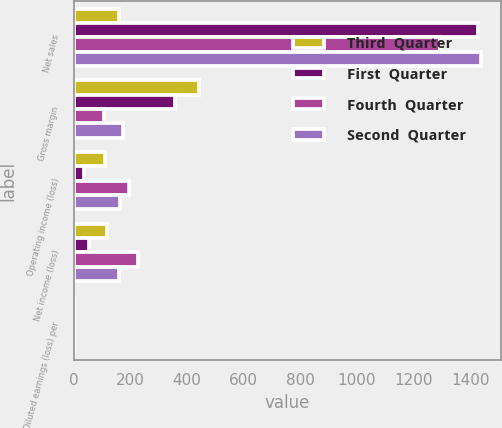Convert chart. <chart><loc_0><loc_0><loc_500><loc_500><stacked_bar_chart><ecel><fcel>Net sales<fcel>Gross margin<fcel>Operating income (loss)<fcel>Net income (loss)<fcel>Diluted earnings (loss) per<nl><fcel>Third  Quarter<fcel>158<fcel>442<fcel>110<fcel>115<fcel>0.15<nl><fcel>First  Quarter<fcel>1427<fcel>357<fcel>34<fcel>52<fcel>0.07<nl><fcel>Fourth  Quarter<fcel>1294<fcel>106<fcel>195<fcel>225<fcel>0.29<nl><fcel>Second  Quarter<fcel>1437<fcel>173<fcel>161<fcel>158<fcel>0.21<nl></chart> 